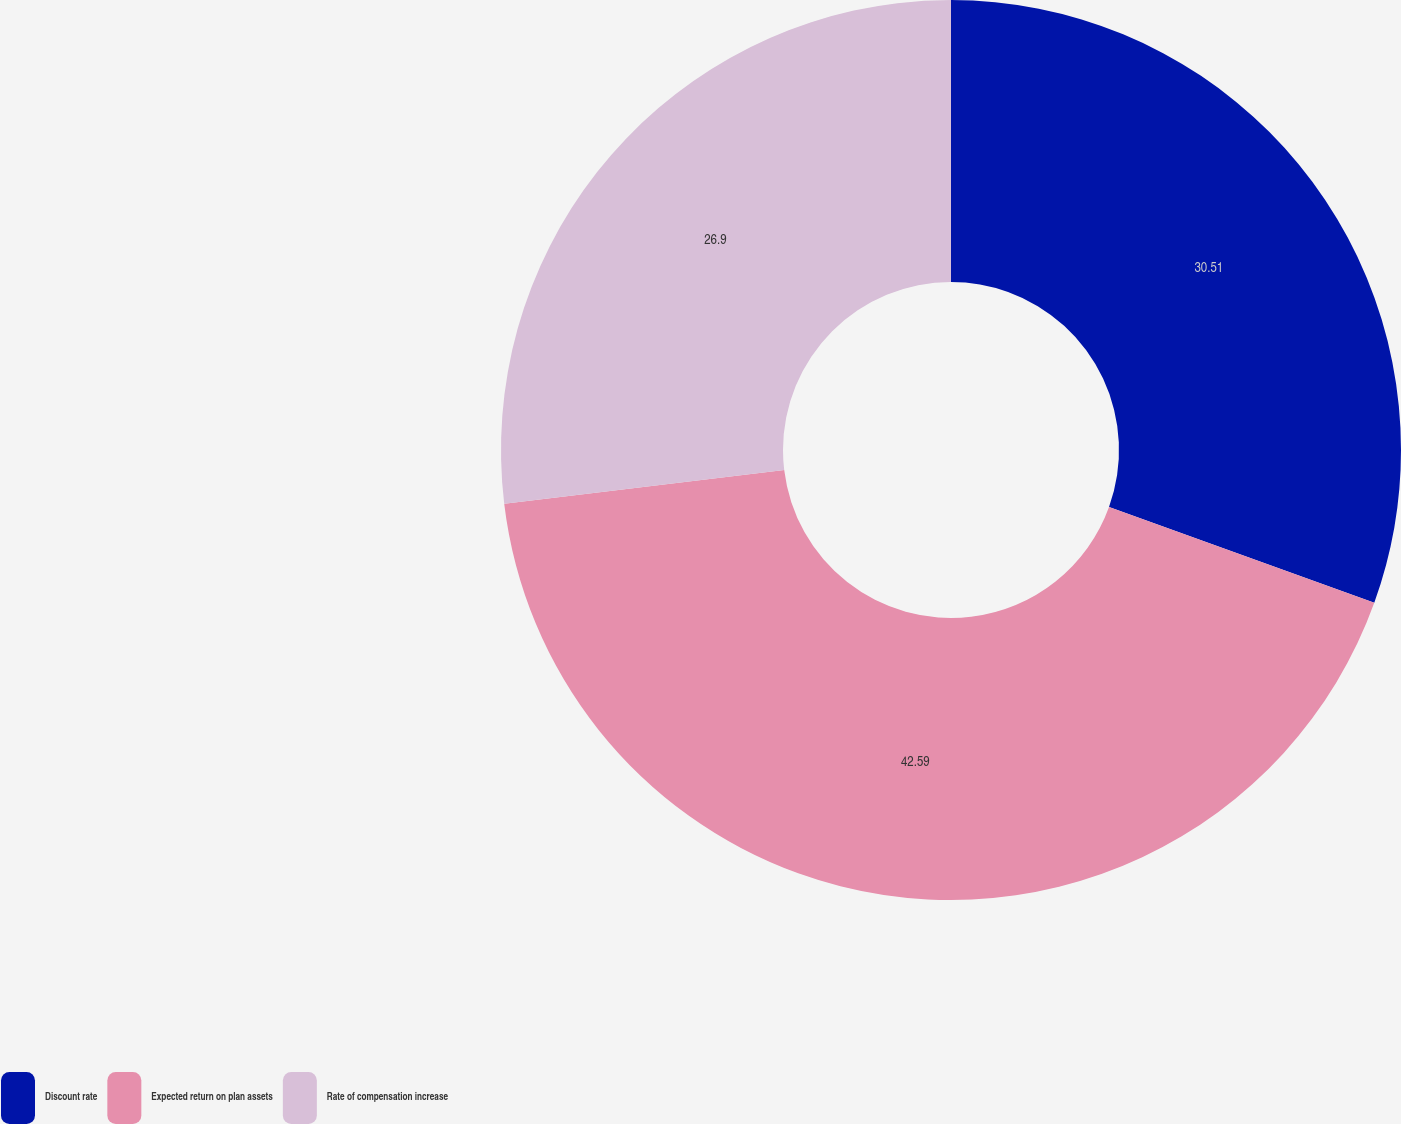Convert chart to OTSL. <chart><loc_0><loc_0><loc_500><loc_500><pie_chart><fcel>Discount rate<fcel>Expected return on plan assets<fcel>Rate of compensation increase<nl><fcel>30.51%<fcel>42.58%<fcel>26.9%<nl></chart> 